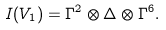Convert formula to latex. <formula><loc_0><loc_0><loc_500><loc_500>I ( V _ { 1 } ) = \Gamma ^ { 2 } \otimes \Delta \otimes \Gamma ^ { 6 } .</formula> 